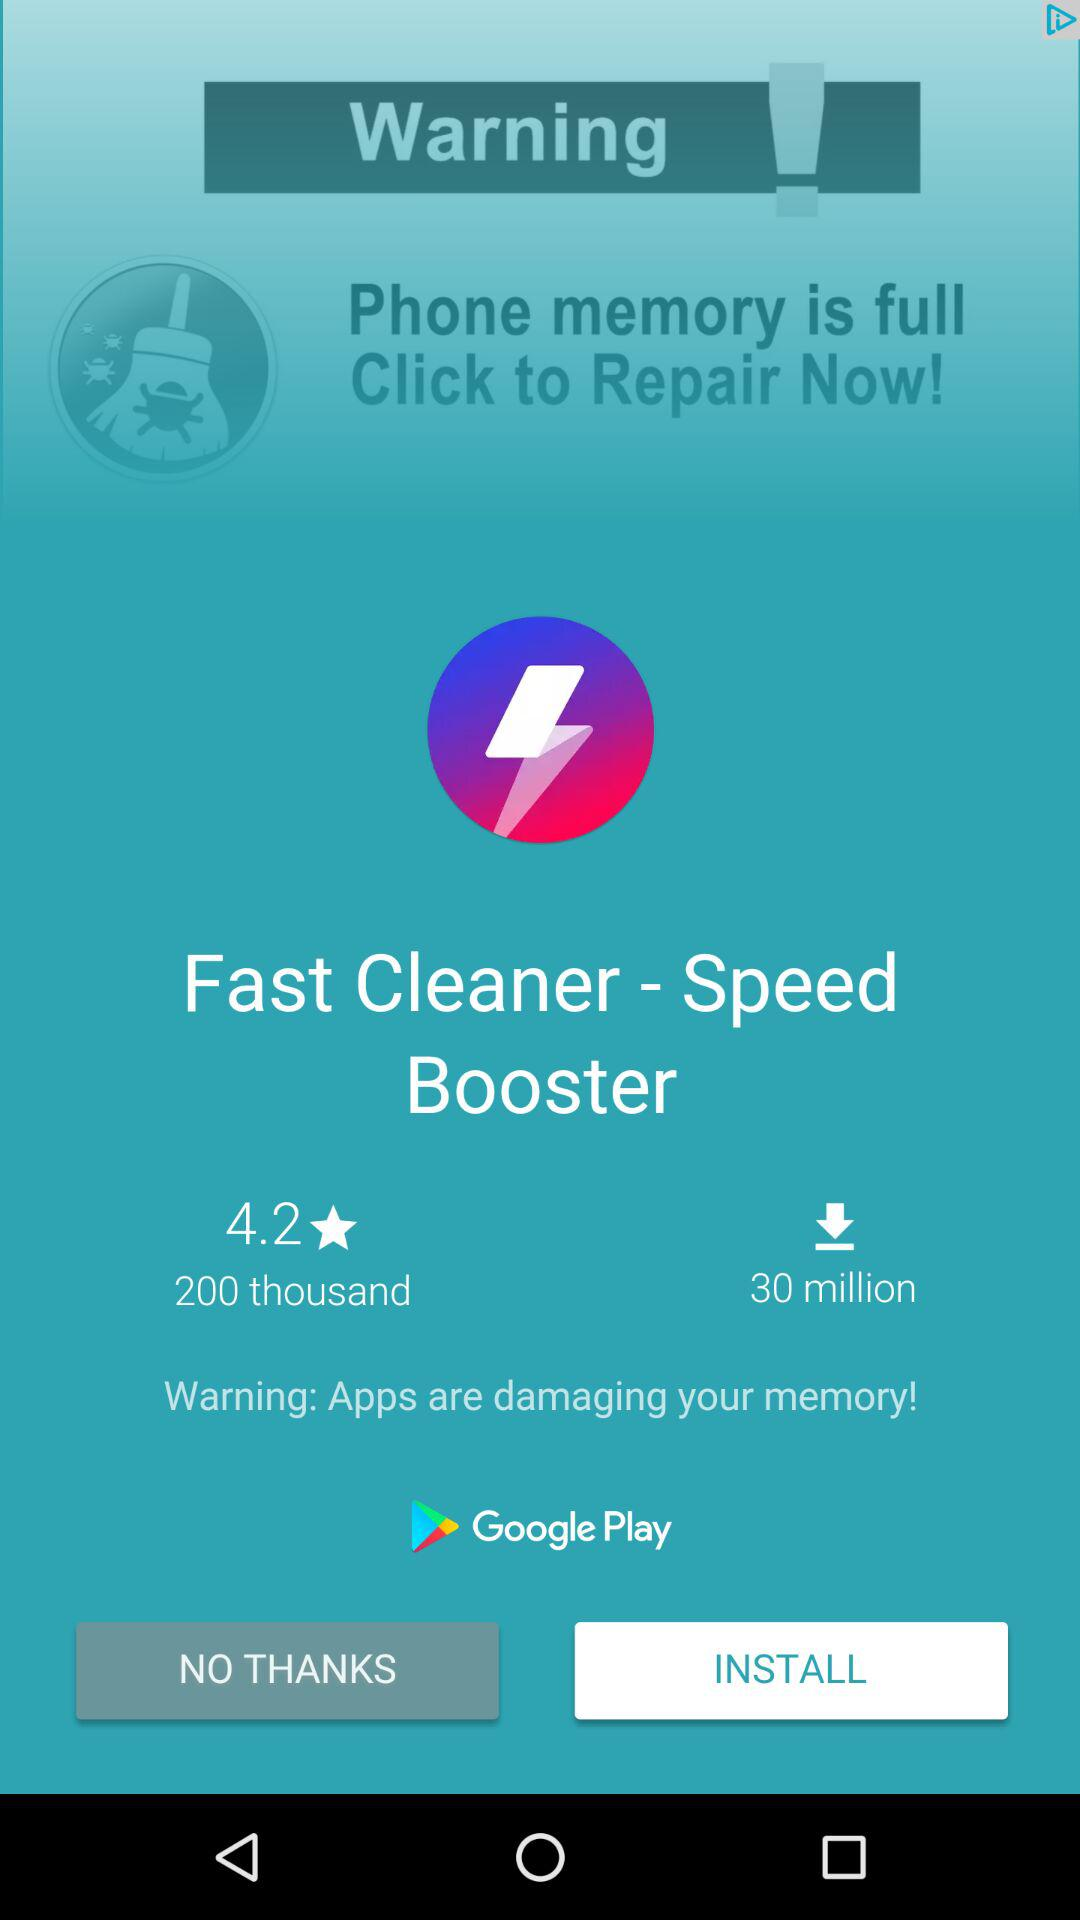How many downloads does the app have?
Answer the question using a single word or phrase. 30 million 